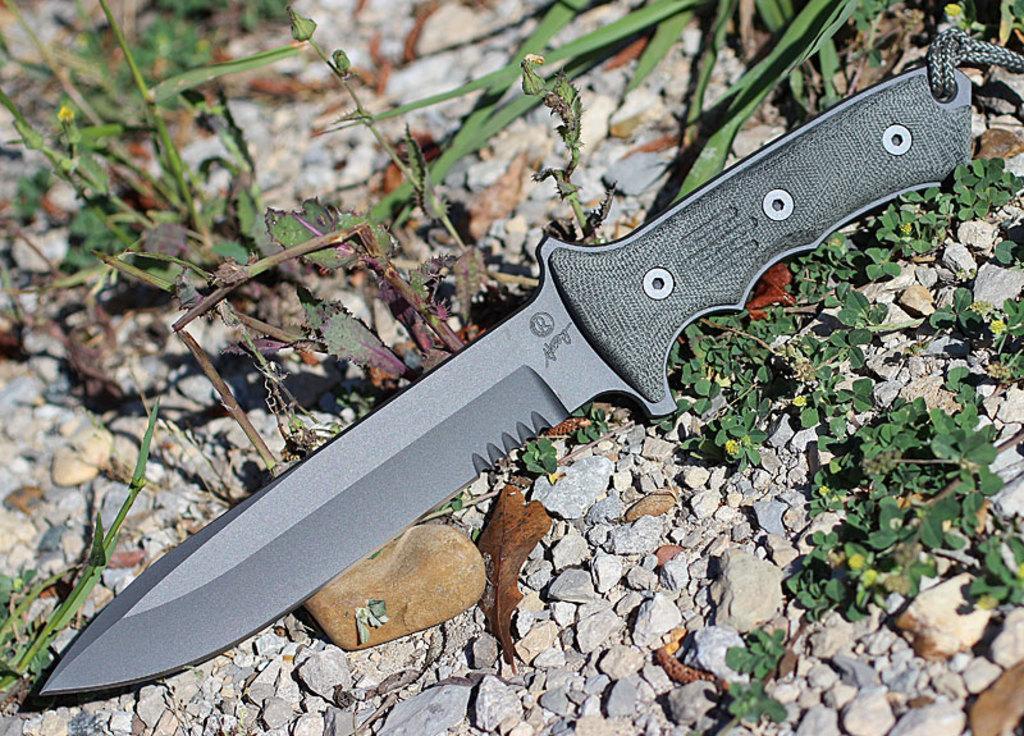Could you give a brief overview of what you see in this image? In this image we can see a knife on a surface. Around the knife we can see a group of stones and plants. 